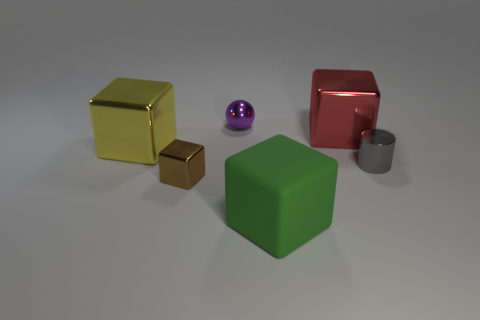Which object in the image appears to be the heaviest, and why? The red cube appears to be the heaviest object in the image based on its size and the assumption that it is made of a solid material with considerable density, such as metal or hard plastic. If these objects were part of a desktop layout, how would you describe their arrangement? The objects are arranged in a deliberate but asymmetric pattern, which might suggest an organized yet dynamic desktop environment. The spacing between each object gives a sense of open composition, inviting interaction or adding to the aesthetic of the space. 